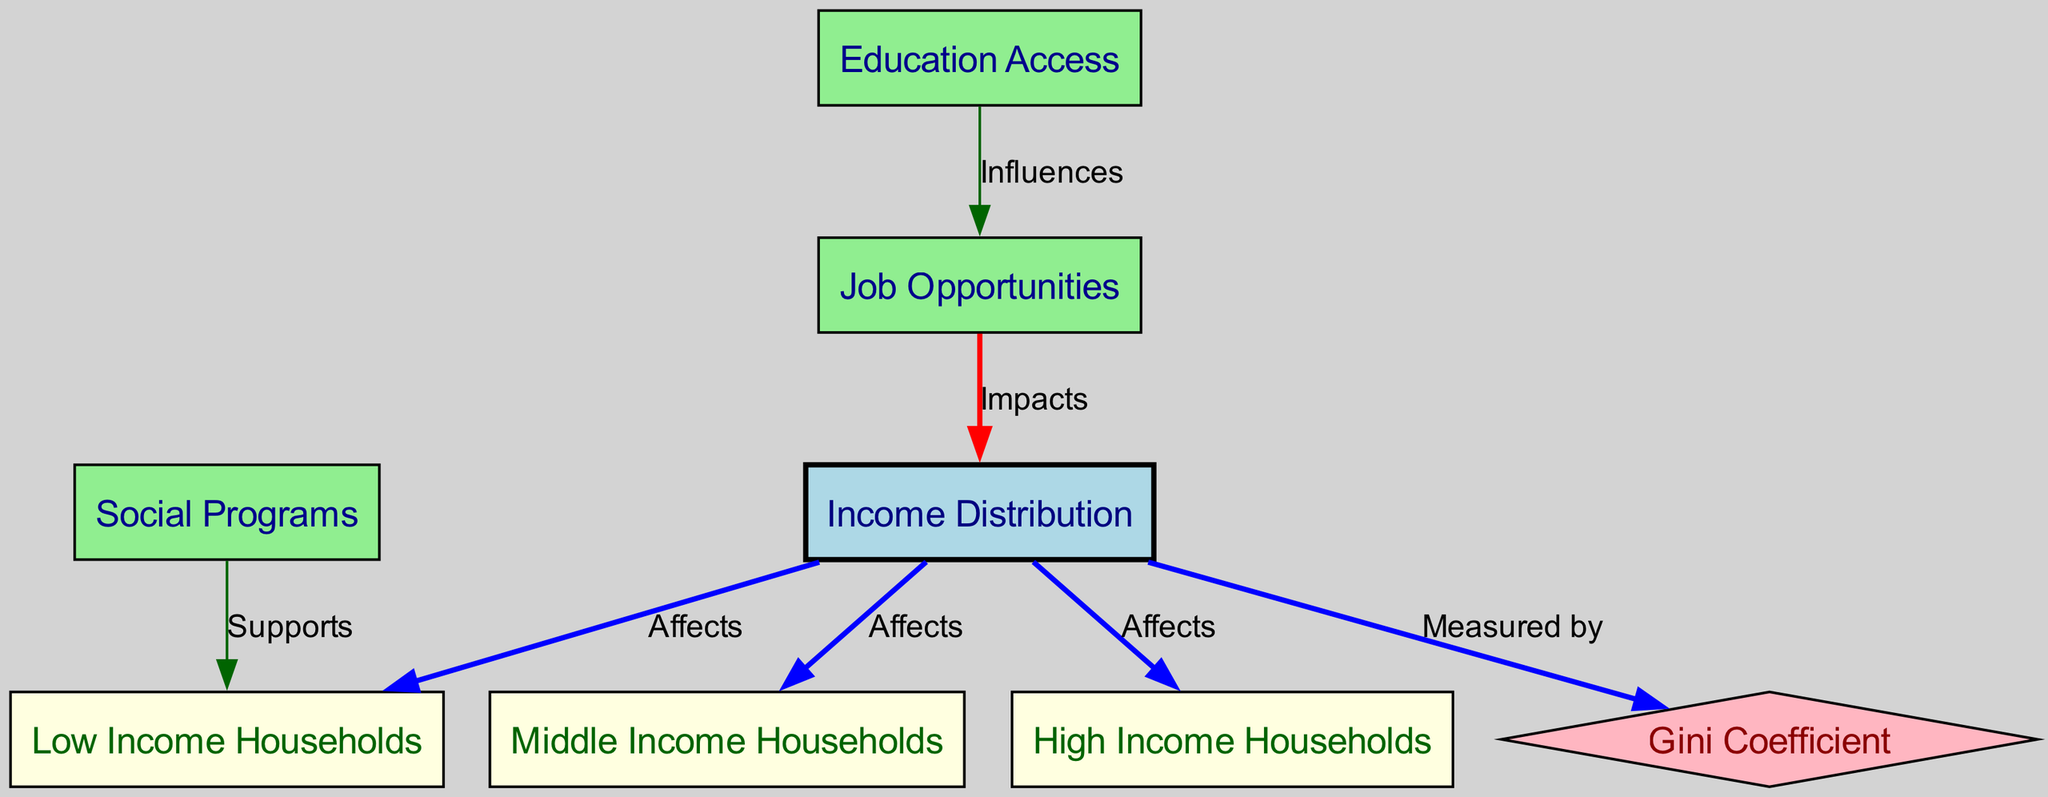What are the three income brackets depicted in the diagram? The diagram lists three income brackets: Low Income, Middle Income, and High Income, clearly marked as nodes.
Answer: Low Income, Middle Income, High Income How many nodes are present in the diagram? By counting the nodes listed, we find there are a total of eight nodes: Income Distribution, Low Income Households, Middle Income Households, High Income Households, Gini Coefficient, Social Programs, Education Access, and Job Opportunities.
Answer: Eight What does the Gini Coefficient represent in this diagram? The Gini Coefficient is represented in the diagram as a measurement, directly connected to the Income Distribution node, indicating how income inequality is assessed within the community.
Answer: Measurement of inequality Which type of households do social programs primarily support according to the diagram? The diagram clearly indicates that Social Programs support Low Income Households, as represented by the directed edge labeled 'Supports' connecting these two nodes.
Answer: Low Income Households How do job opportunities impact income distribution? The diagram shows a directed edge from Job Opportunities to Income Distribution labeled 'Impacts', indicating a direct relationship where changes in job opportunities affect the overall income distribution.
Answer: Impacts What is the relationship between education access and job opportunities according to the diagram? The diagram establishes that Education Access influences Job Opportunities, as indicated by the directed edge labeled 'Influences'. This reflects that better education can lead to increased job availability.
Answer: Influences How does income distribution affect the Gini coefficient? The diagram illustrates that income distribution is measured by the Gini Coefficient, which means variations in income distribution will directly influence the level of income inequality indicated by the Gini coefficient.
Answer: Measured by Which node has the highest level of connection based on the diagram? Observing the diagram reveals that Income Distribution connects to three different nodes: Low Income Households, Middle Income Households, and High Income Households. This indicates it has the highest level of connectedness compared to other nodes.
Answer: Income Distribution 